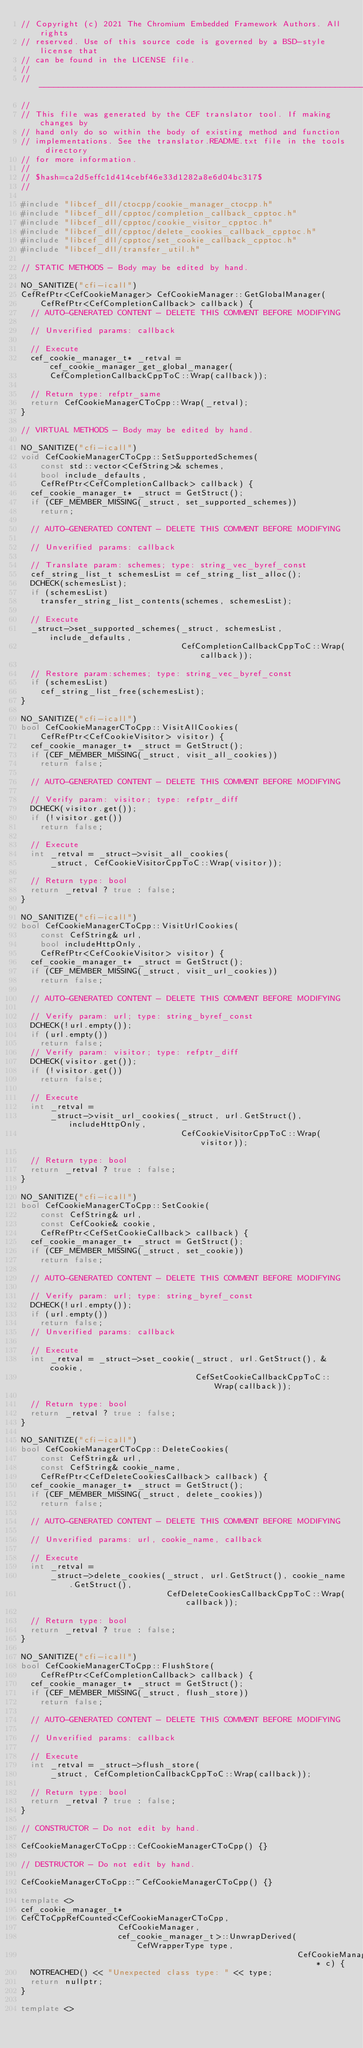Convert code to text. <code><loc_0><loc_0><loc_500><loc_500><_C++_>// Copyright (c) 2021 The Chromium Embedded Framework Authors. All rights
// reserved. Use of this source code is governed by a BSD-style license that
// can be found in the LICENSE file.
//
// ---------------------------------------------------------------------------
//
// This file was generated by the CEF translator tool. If making changes by
// hand only do so within the body of existing method and function
// implementations. See the translator.README.txt file in the tools directory
// for more information.
//
// $hash=ca2d5effc1d414cebf46e33d1282a8e6d04bc317$
//

#include "libcef_dll/ctocpp/cookie_manager_ctocpp.h"
#include "libcef_dll/cpptoc/completion_callback_cpptoc.h"
#include "libcef_dll/cpptoc/cookie_visitor_cpptoc.h"
#include "libcef_dll/cpptoc/delete_cookies_callback_cpptoc.h"
#include "libcef_dll/cpptoc/set_cookie_callback_cpptoc.h"
#include "libcef_dll/transfer_util.h"

// STATIC METHODS - Body may be edited by hand.

NO_SANITIZE("cfi-icall")
CefRefPtr<CefCookieManager> CefCookieManager::GetGlobalManager(
    CefRefPtr<CefCompletionCallback> callback) {
  // AUTO-GENERATED CONTENT - DELETE THIS COMMENT BEFORE MODIFYING

  // Unverified params: callback

  // Execute
  cef_cookie_manager_t* _retval = cef_cookie_manager_get_global_manager(
      CefCompletionCallbackCppToC::Wrap(callback));

  // Return type: refptr_same
  return CefCookieManagerCToCpp::Wrap(_retval);
}

// VIRTUAL METHODS - Body may be edited by hand.

NO_SANITIZE("cfi-icall")
void CefCookieManagerCToCpp::SetSupportedSchemes(
    const std::vector<CefString>& schemes,
    bool include_defaults,
    CefRefPtr<CefCompletionCallback> callback) {
  cef_cookie_manager_t* _struct = GetStruct();
  if (CEF_MEMBER_MISSING(_struct, set_supported_schemes))
    return;

  // AUTO-GENERATED CONTENT - DELETE THIS COMMENT BEFORE MODIFYING

  // Unverified params: callback

  // Translate param: schemes; type: string_vec_byref_const
  cef_string_list_t schemesList = cef_string_list_alloc();
  DCHECK(schemesList);
  if (schemesList)
    transfer_string_list_contents(schemes, schemesList);

  // Execute
  _struct->set_supported_schemes(_struct, schemesList, include_defaults,
                                 CefCompletionCallbackCppToC::Wrap(callback));

  // Restore param:schemes; type: string_vec_byref_const
  if (schemesList)
    cef_string_list_free(schemesList);
}

NO_SANITIZE("cfi-icall")
bool CefCookieManagerCToCpp::VisitAllCookies(
    CefRefPtr<CefCookieVisitor> visitor) {
  cef_cookie_manager_t* _struct = GetStruct();
  if (CEF_MEMBER_MISSING(_struct, visit_all_cookies))
    return false;

  // AUTO-GENERATED CONTENT - DELETE THIS COMMENT BEFORE MODIFYING

  // Verify param: visitor; type: refptr_diff
  DCHECK(visitor.get());
  if (!visitor.get())
    return false;

  // Execute
  int _retval = _struct->visit_all_cookies(
      _struct, CefCookieVisitorCppToC::Wrap(visitor));

  // Return type: bool
  return _retval ? true : false;
}

NO_SANITIZE("cfi-icall")
bool CefCookieManagerCToCpp::VisitUrlCookies(
    const CefString& url,
    bool includeHttpOnly,
    CefRefPtr<CefCookieVisitor> visitor) {
  cef_cookie_manager_t* _struct = GetStruct();
  if (CEF_MEMBER_MISSING(_struct, visit_url_cookies))
    return false;

  // AUTO-GENERATED CONTENT - DELETE THIS COMMENT BEFORE MODIFYING

  // Verify param: url; type: string_byref_const
  DCHECK(!url.empty());
  if (url.empty())
    return false;
  // Verify param: visitor; type: refptr_diff
  DCHECK(visitor.get());
  if (!visitor.get())
    return false;

  // Execute
  int _retval =
      _struct->visit_url_cookies(_struct, url.GetStruct(), includeHttpOnly,
                                 CefCookieVisitorCppToC::Wrap(visitor));

  // Return type: bool
  return _retval ? true : false;
}

NO_SANITIZE("cfi-icall")
bool CefCookieManagerCToCpp::SetCookie(
    const CefString& url,
    const CefCookie& cookie,
    CefRefPtr<CefSetCookieCallback> callback) {
  cef_cookie_manager_t* _struct = GetStruct();
  if (CEF_MEMBER_MISSING(_struct, set_cookie))
    return false;

  // AUTO-GENERATED CONTENT - DELETE THIS COMMENT BEFORE MODIFYING

  // Verify param: url; type: string_byref_const
  DCHECK(!url.empty());
  if (url.empty())
    return false;
  // Unverified params: callback

  // Execute
  int _retval = _struct->set_cookie(_struct, url.GetStruct(), &cookie,
                                    CefSetCookieCallbackCppToC::Wrap(callback));

  // Return type: bool
  return _retval ? true : false;
}

NO_SANITIZE("cfi-icall")
bool CefCookieManagerCToCpp::DeleteCookies(
    const CefString& url,
    const CefString& cookie_name,
    CefRefPtr<CefDeleteCookiesCallback> callback) {
  cef_cookie_manager_t* _struct = GetStruct();
  if (CEF_MEMBER_MISSING(_struct, delete_cookies))
    return false;

  // AUTO-GENERATED CONTENT - DELETE THIS COMMENT BEFORE MODIFYING

  // Unverified params: url, cookie_name, callback

  // Execute
  int _retval =
      _struct->delete_cookies(_struct, url.GetStruct(), cookie_name.GetStruct(),
                              CefDeleteCookiesCallbackCppToC::Wrap(callback));

  // Return type: bool
  return _retval ? true : false;
}

NO_SANITIZE("cfi-icall")
bool CefCookieManagerCToCpp::FlushStore(
    CefRefPtr<CefCompletionCallback> callback) {
  cef_cookie_manager_t* _struct = GetStruct();
  if (CEF_MEMBER_MISSING(_struct, flush_store))
    return false;

  // AUTO-GENERATED CONTENT - DELETE THIS COMMENT BEFORE MODIFYING

  // Unverified params: callback

  // Execute
  int _retval = _struct->flush_store(
      _struct, CefCompletionCallbackCppToC::Wrap(callback));

  // Return type: bool
  return _retval ? true : false;
}

// CONSTRUCTOR - Do not edit by hand.

CefCookieManagerCToCpp::CefCookieManagerCToCpp() {}

// DESTRUCTOR - Do not edit by hand.

CefCookieManagerCToCpp::~CefCookieManagerCToCpp() {}

template <>
cef_cookie_manager_t*
CefCToCppRefCounted<CefCookieManagerCToCpp,
                    CefCookieManager,
                    cef_cookie_manager_t>::UnwrapDerived(CefWrapperType type,
                                                         CefCookieManager* c) {
  NOTREACHED() << "Unexpected class type: " << type;
  return nullptr;
}

template <></code> 